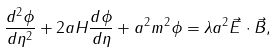<formula> <loc_0><loc_0><loc_500><loc_500>\frac { d ^ { 2 } \phi } { d \eta ^ { 2 } } + 2 a H \frac { d \phi } { d \eta } + a ^ { 2 } m ^ { 2 } \phi = \lambda a ^ { 2 } { \vec { E } } \cdot { \vec { B } } ,</formula> 